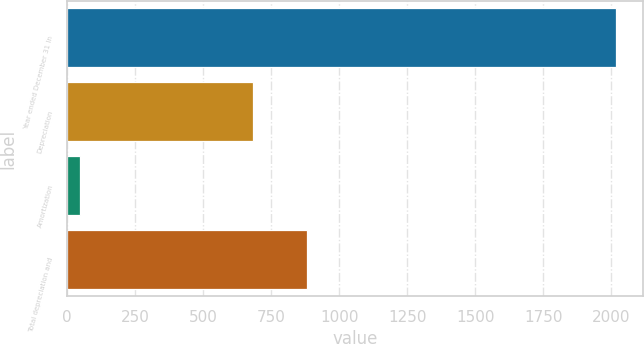Convert chart. <chart><loc_0><loc_0><loc_500><loc_500><bar_chart><fcel>Year ended December 31 In<fcel>Depreciation<fcel>Amortization<fcel>Total depreciation and<nl><fcel>2016<fcel>683<fcel>46<fcel>880<nl></chart> 